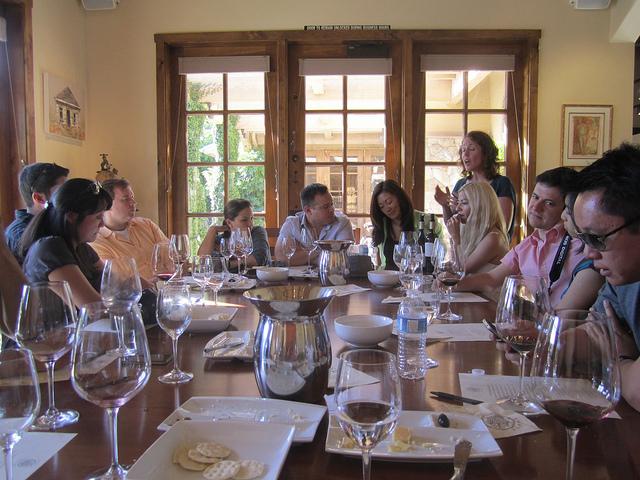What type of glasses are these?
Be succinct. Wine. How many windows are there?
Concise answer only. 3. Are the glasses empty?
Write a very short answer. Yes. How many cups are in the picture?
Be succinct. 0. How many people are seated at the table?
Answer briefly. 10. 